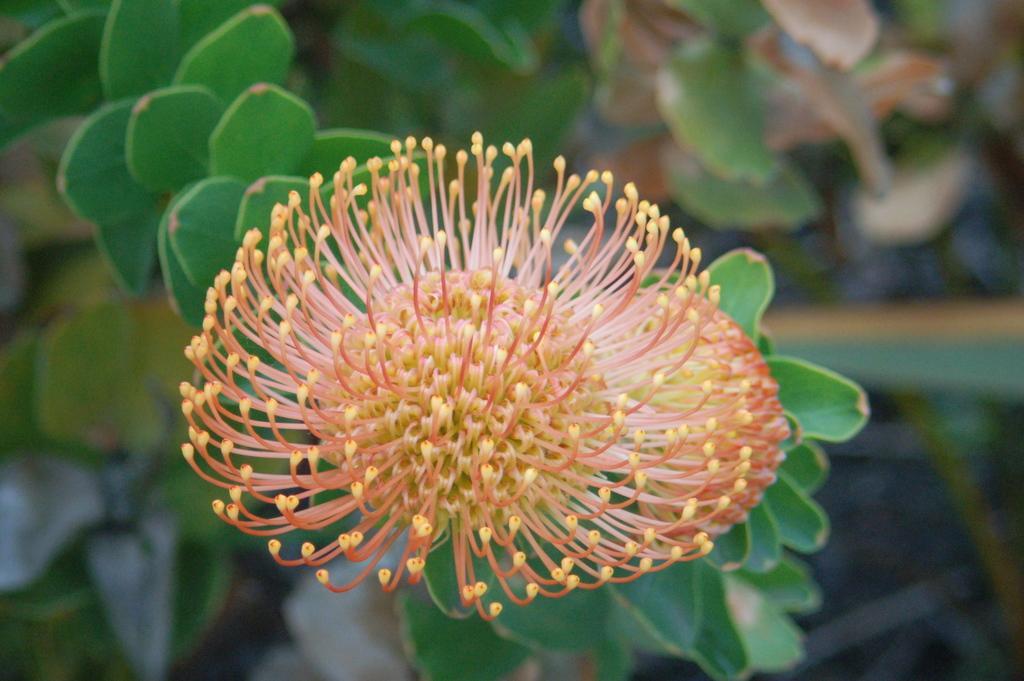Could you give a brief overview of what you see in this image? In this image I can see the flower in orange and yellow color and few leaves in green color. Background is blurred. 